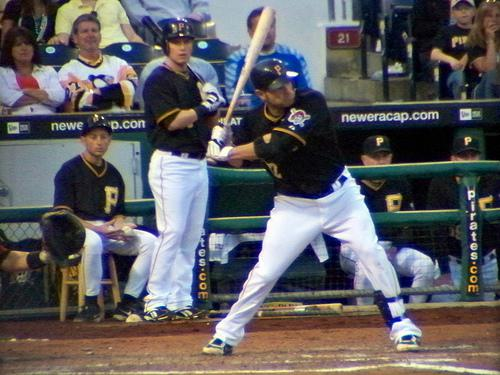Question: what game is taking place in this photo?
Choices:
A. Soccer.
B. Catch.
C. Softball.
D. Baseball.
Answer with the letter. Answer: D Question: how is the man in foreground holding bat?
Choices:
A. With his left hand.
B. In both hands.
C. With his right hand.
D. Between his legs.
Answer with the letter. Answer: B Question: why is the man holding bat in this position?
Choices:
A. He's at bat.
B. Ready to swing.
C. He's on deck.
D. He just swung.
Answer with the letter. Answer: B Question: what color are the batters pants?
Choices:
A. Black.
B. White.
C. Red.
D. Orange.
Answer with the letter. Answer: B Question: what letter do the players in dugout and sitting to left of dugout have on their shirts?
Choices:
A. P.
B. W.
C. C.
D. N.
Answer with the letter. Answer: A Question: where might this game be taking place?
Choices:
A. Yankee stadium.
B. A little league field.
C. College world series.
D. Baseball field.
Answer with the letter. Answer: D 